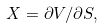Convert formula to latex. <formula><loc_0><loc_0><loc_500><loc_500>X = \partial V / \partial S ,</formula> 